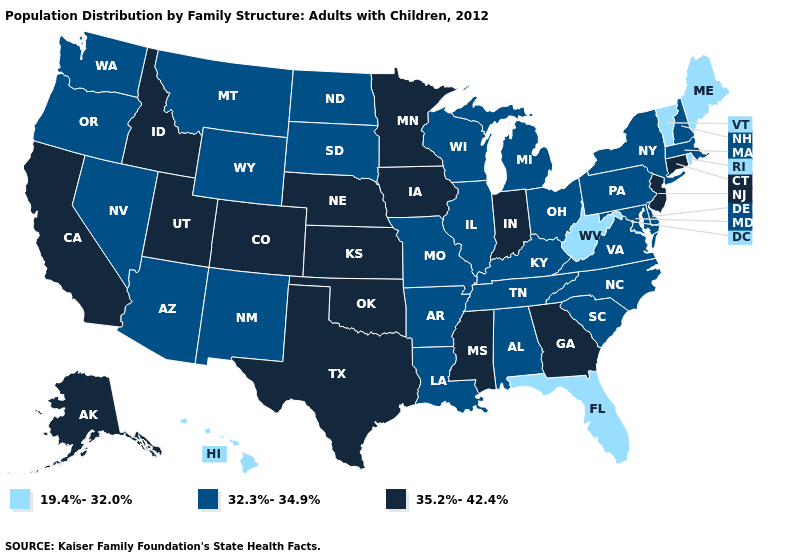Does Utah have a higher value than Missouri?
Be succinct. Yes. Name the states that have a value in the range 35.2%-42.4%?
Answer briefly. Alaska, California, Colorado, Connecticut, Georgia, Idaho, Indiana, Iowa, Kansas, Minnesota, Mississippi, Nebraska, New Jersey, Oklahoma, Texas, Utah. What is the value of Arizona?
Be succinct. 32.3%-34.9%. Among the states that border Idaho , does Utah have the highest value?
Keep it brief. Yes. Which states hav the highest value in the Northeast?
Concise answer only. Connecticut, New Jersey. Name the states that have a value in the range 35.2%-42.4%?
Be succinct. Alaska, California, Colorado, Connecticut, Georgia, Idaho, Indiana, Iowa, Kansas, Minnesota, Mississippi, Nebraska, New Jersey, Oklahoma, Texas, Utah. Name the states that have a value in the range 35.2%-42.4%?
Short answer required. Alaska, California, Colorado, Connecticut, Georgia, Idaho, Indiana, Iowa, Kansas, Minnesota, Mississippi, Nebraska, New Jersey, Oklahoma, Texas, Utah. Among the states that border Connecticut , which have the lowest value?
Concise answer only. Rhode Island. What is the value of Michigan?
Concise answer only. 32.3%-34.9%. Is the legend a continuous bar?
Answer briefly. No. What is the value of Montana?
Give a very brief answer. 32.3%-34.9%. Name the states that have a value in the range 32.3%-34.9%?
Give a very brief answer. Alabama, Arizona, Arkansas, Delaware, Illinois, Kentucky, Louisiana, Maryland, Massachusetts, Michigan, Missouri, Montana, Nevada, New Hampshire, New Mexico, New York, North Carolina, North Dakota, Ohio, Oregon, Pennsylvania, South Carolina, South Dakota, Tennessee, Virginia, Washington, Wisconsin, Wyoming. Is the legend a continuous bar?
Write a very short answer. No. What is the value of Maine?
Answer briefly. 19.4%-32.0%. 